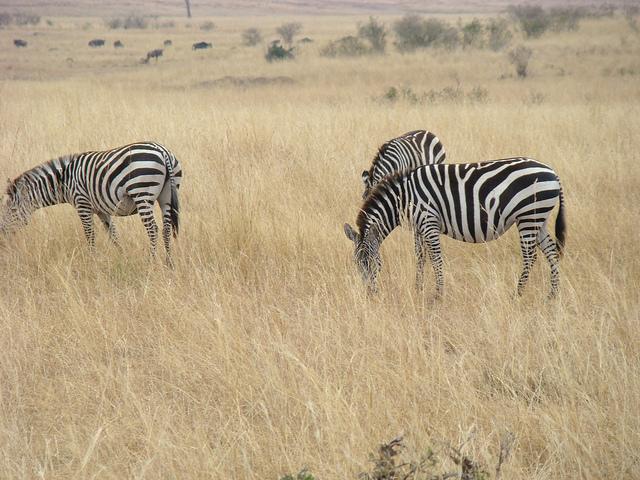What are the zebra doing?
Be succinct. Grazing. What color is the grass?
Answer briefly. Brown. How many zebras can be seen?
Be succinct. 3. How many zebra are in the picture?
Keep it brief. 3. 